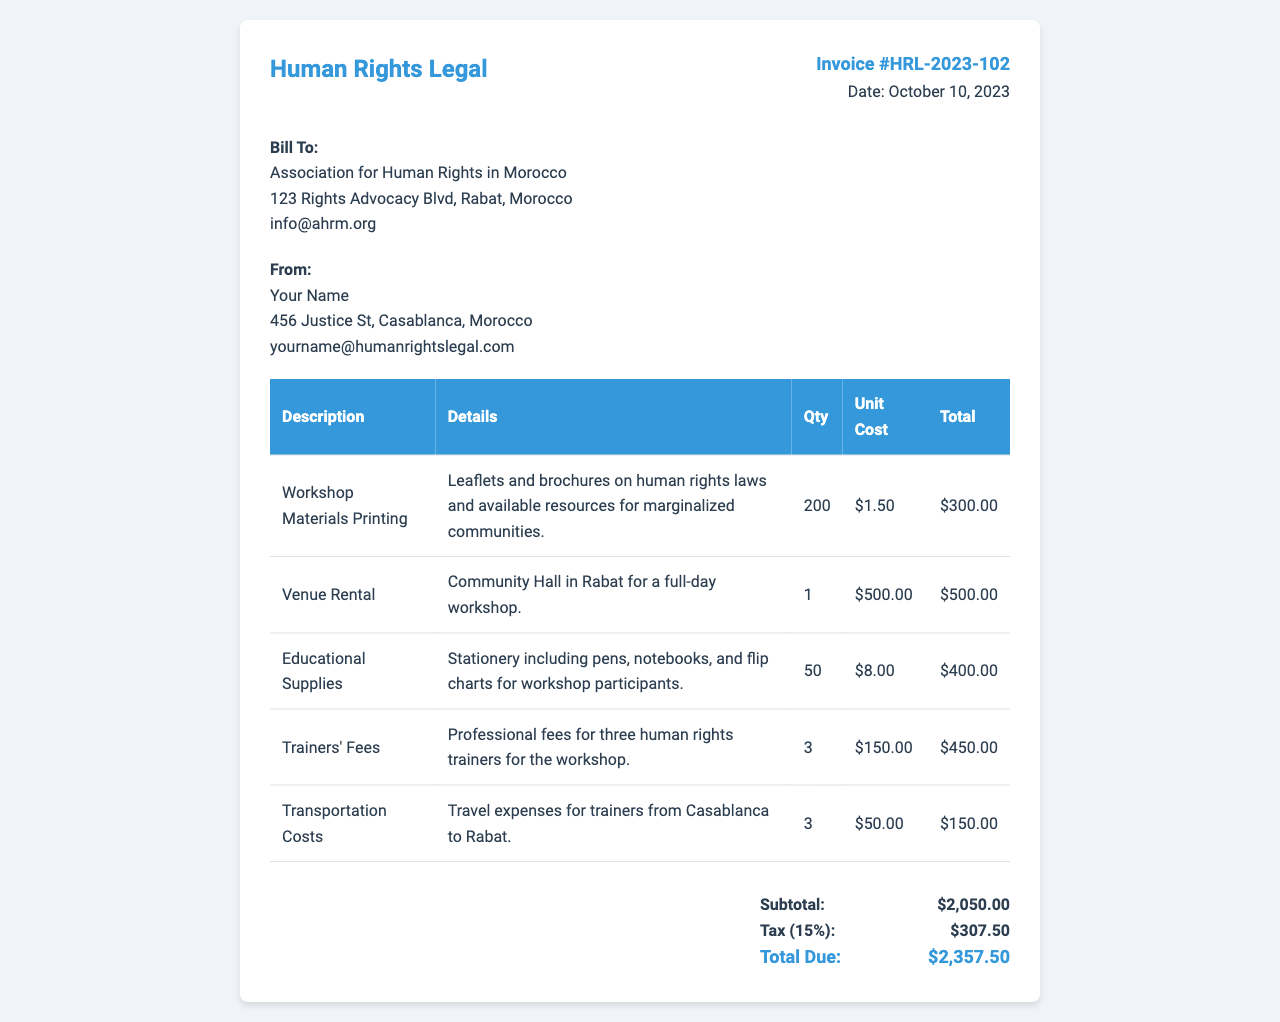What is the invoice number? The invoice number is a specific identifier for this billing statement, which is provided in the document.
Answer: HRL-2023-102 Who is the biller? The name of the person or entity that is issuing the invoice is specified in the document.
Answer: Your Name What is the total amount due? The total amount due is the final amount that needs to be paid, calculated after tax on the subtotal.
Answer: $2,357.50 How many workshop materials were printed? The quantity of printed materials is listed in the description of the associated expense.
Answer: 200 What is the cost per unit for educational supplies? The unit cost for educational supplies is found in the relevant section of the invoice detailing the expense.
Answer: $8.00 What percentage is the tax applied to the subtotal? The tax rate that is applied to the subtotal is stated in the invoice.
Answer: 15% Which venue was rented for the workshop? The name and location of the venue rented for the event are provided in the details of the expense.
Answer: Community Hall in Rabat How many trainers provided their services? The number of trainers involved in the workshop is specified within the Trainers' Fees line item.
Answer: 3 What is the subtotal amount before tax? The subtotal amount is the total of all expenses listed before any tax is applied.
Answer: $2,050.00 